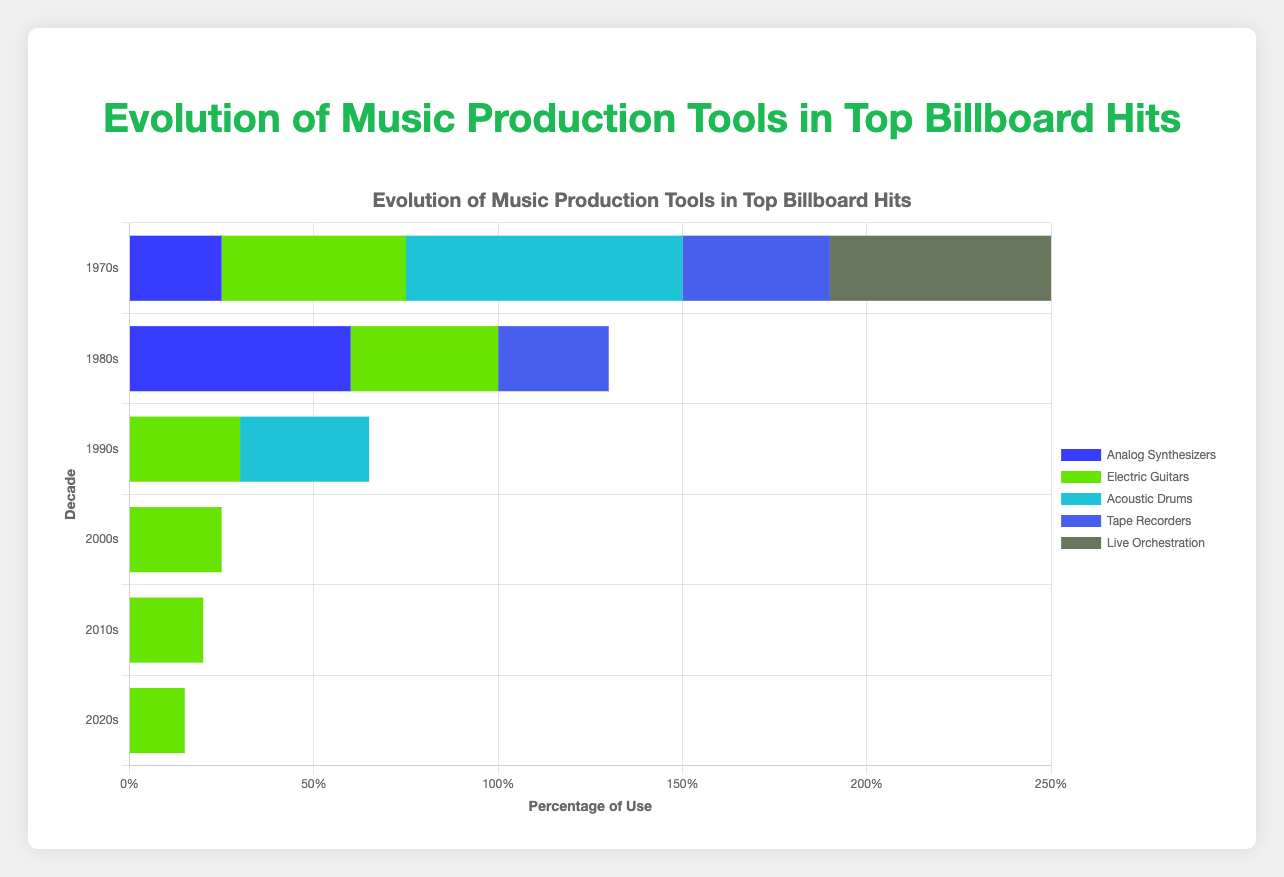Which decade saw the most significant increase in the use of digital synthesizers compared to the previous decade? To find the most significant increase, compare the values of digital synthesizers across the decades. The shift from 1980s (40%) to 1990s (70%) represents an increase of 30%, which is the largest change.
Answer: 1990s Which tool showed the highest percentage of use in the 2020s? Look at the horizontal bars for each tool in the 2020s section, the bar labeled 'Auto-Tune' and 'Software Synths' both reach the highest percentage of 90%.
Answer: Auto-Tune, Software Synths How did the use of electric guitars change from the 1970s to the 2020s? Compare the percentage of use of electric guitars for the two decades: it was 50% in the 1970s and decreased to 15% in the 2020s, a decline of 35%.
Answer: Decreased by 35% Which new tool appeared in the 2010s that was not used in previous decades? Identify tools in the 2010s that are not found in earlier decades; 'Cloud-Based Production Tools' appears for the first time in the 2010s.
Answer: Cloud-Based Production Tools Which decade saw the use of the most diverse range of tools? Count the distinct tools used in each decade; the 2020s has the most tools listed (9 in total).
Answer: 2020s What was the difference in the use of MIDI technology between the 1980s and 1990s? MIDI technology was used 50% in the 1980s and 65% in the 1990s, a difference of 15%.
Answer: 15% How has the use of acoustic drums changed over the decades? Compare the use of acoustic drums for each decade: 75% (1970s), 0% (1980s), 35% (1990s), 0% (2000s), 0% (2010s), 0% (2020s). It was used frequently in the 1970s and 1990s, but not much later.
Answer: Declined over time Which tool saw the greatest increase in use from the 2000s to the 2010s? Compare each tool's usage between the 2000s and 2010s. 'Auto-Tune' increases from 70% (2000s) to 85% (2010s), an increase of 15%.
Answer: Auto-Tune 